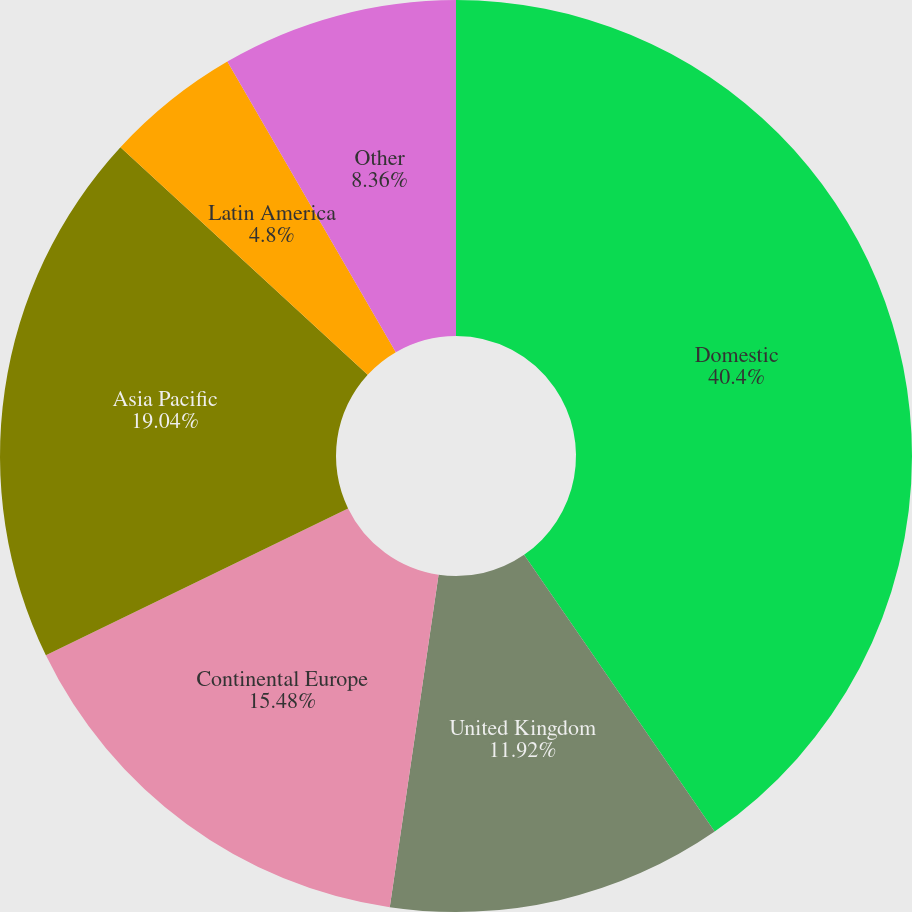Convert chart to OTSL. <chart><loc_0><loc_0><loc_500><loc_500><pie_chart><fcel>Domestic<fcel>United Kingdom<fcel>Continental Europe<fcel>Asia Pacific<fcel>Latin America<fcel>Other<nl><fcel>40.4%<fcel>11.92%<fcel>15.48%<fcel>19.04%<fcel>4.8%<fcel>8.36%<nl></chart> 